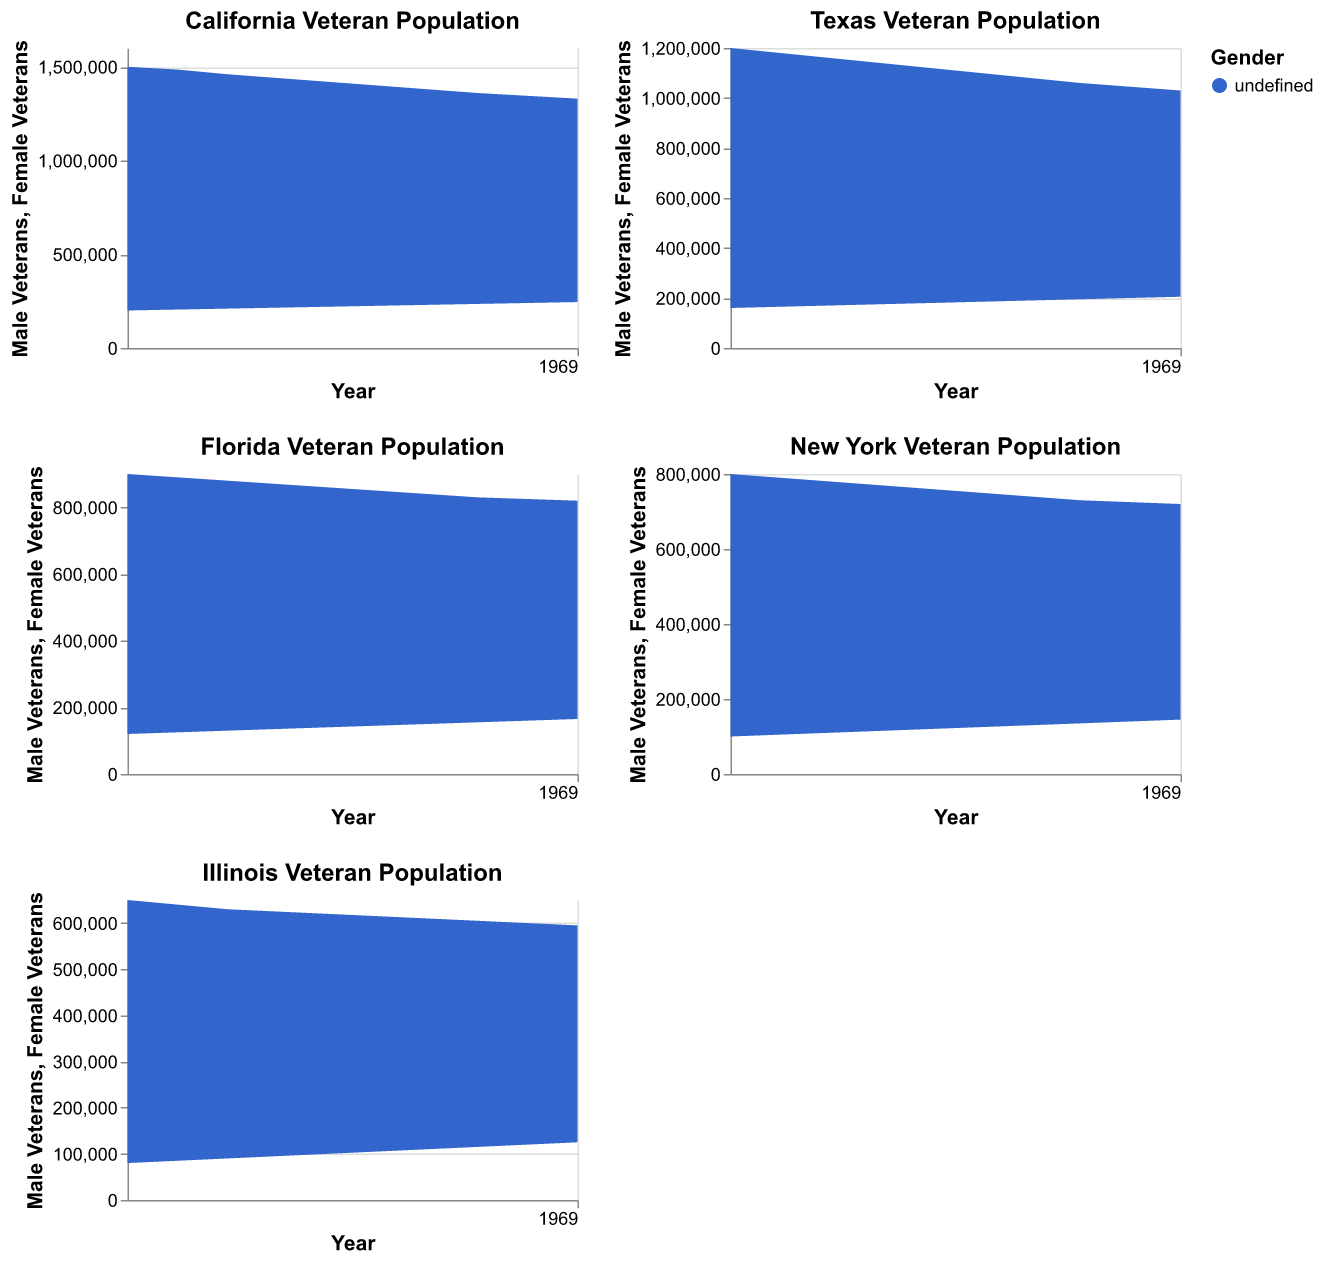What is the title of the subplot for Illinois? The subplot titles are displayed at the top of each individual chart. The one for Illinois will have 'Illinois' in it.
Answer: Illinois Veteran Population How many male veterans were there in California in 2015? Look at the California chart for the year 2015 and find the value for Male Veterans on the y-axis.
Answer: 1,460,000 By how much did the number of female veterans in Texas increase from 2013 to 2022? Subtract the number of female veterans in Texas in 2013 from the value in 2022. Specifically, 205,000 (2022) - 160,000 (2013).
Answer: 45,000 Which state had the smallest number of female veterans in 2013? Compare the female veteran counts in 2013 across all subplots: California, Texas, Florida, New York, and Illinois. The smallest number will be the value for Illinois.
Answer: Illinois What can you infer about the trend of male veterans in Florida from 2013 to 2022? Observe the area representing male veterans in Florida over the years from 2013 to 2022. Note the general direction of the trend (increasing, decreasing, or constant).
Answer: Decreasing Which states showed an increase in the number of female veterans from 2020 to 2022? Check the subplots for each state and focus on the female veteran area between 2020 and 2022. Identify states where the number increased.
Answer: All states How did the number of male veterans in New York change between 2014 and 2015? Look at the New York subplot and compare the y-values for male veterans between the years 2014 and 2015. Identify if there is an increase, decrease, or no change.
Answer: Decrease Compare the overall number of veterans (male + female) in Illinois in 2018 and in California in 2022. Which state had more veterans in those years? Sum male and female veterans in Illinois for 2018 and compare it with the sum for California in 2022.
Answer: California What is the general trend in the number of veterans in Illinois over the decade? Analyze the Illinois subplot from 2013 to 2022 and describe the overall trend for both male and female veterans.
Answer: Decreasing Which state had the largest number of female veterans in 2019? Compare the female veteran counts in 2019 across all subplots and identify the state with the largest number.
Answer: California 